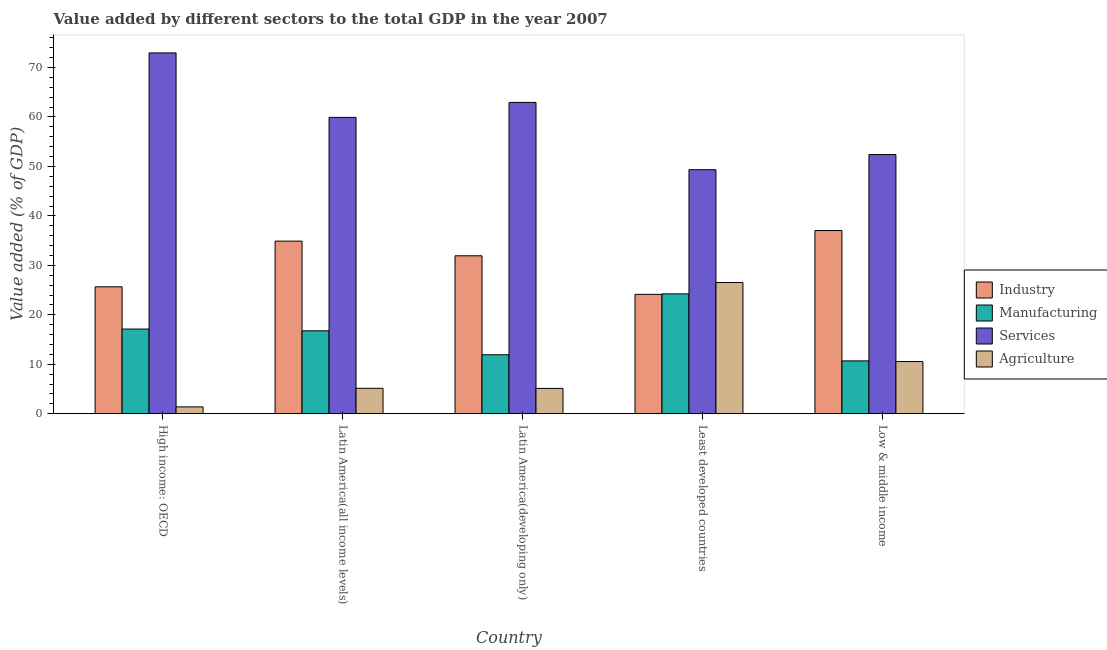How many different coloured bars are there?
Offer a terse response. 4. How many groups of bars are there?
Offer a very short reply. 5. Are the number of bars per tick equal to the number of legend labels?
Your answer should be very brief. Yes. Are the number of bars on each tick of the X-axis equal?
Offer a terse response. Yes. What is the value added by manufacturing sector in Low & middle income?
Offer a terse response. 10.68. Across all countries, what is the maximum value added by manufacturing sector?
Give a very brief answer. 24.24. Across all countries, what is the minimum value added by manufacturing sector?
Give a very brief answer. 10.68. In which country was the value added by industrial sector maximum?
Offer a terse response. Low & middle income. In which country was the value added by industrial sector minimum?
Provide a succinct answer. Least developed countries. What is the total value added by industrial sector in the graph?
Your answer should be compact. 153.68. What is the difference between the value added by services sector in Latin America(all income levels) and that in Latin America(developing only)?
Provide a succinct answer. -3.03. What is the difference between the value added by industrial sector in High income: OECD and the value added by services sector in Least developed countries?
Make the answer very short. -23.68. What is the average value added by manufacturing sector per country?
Your answer should be compact. 16.15. What is the difference between the value added by agricultural sector and value added by services sector in Latin America(all income levels)?
Make the answer very short. -54.77. In how many countries, is the value added by industrial sector greater than 38 %?
Offer a very short reply. 0. What is the ratio of the value added by manufacturing sector in High income: OECD to that in Least developed countries?
Keep it short and to the point. 0.71. Is the difference between the value added by manufacturing sector in High income: OECD and Latin America(developing only) greater than the difference between the value added by agricultural sector in High income: OECD and Latin America(developing only)?
Your response must be concise. Yes. What is the difference between the highest and the second highest value added by agricultural sector?
Offer a terse response. 15.98. What is the difference between the highest and the lowest value added by services sector?
Make the answer very short. 23.61. In how many countries, is the value added by services sector greater than the average value added by services sector taken over all countries?
Provide a short and direct response. 3. Is it the case that in every country, the sum of the value added by industrial sector and value added by manufacturing sector is greater than the sum of value added by agricultural sector and value added by services sector?
Your answer should be very brief. Yes. What does the 3rd bar from the left in High income: OECD represents?
Offer a terse response. Services. What does the 2nd bar from the right in Latin America(all income levels) represents?
Ensure brevity in your answer.  Services. Is it the case that in every country, the sum of the value added by industrial sector and value added by manufacturing sector is greater than the value added by services sector?
Ensure brevity in your answer.  No. How many bars are there?
Make the answer very short. 20. How many countries are there in the graph?
Give a very brief answer. 5. What is the difference between two consecutive major ticks on the Y-axis?
Your response must be concise. 10. Are the values on the major ticks of Y-axis written in scientific E-notation?
Make the answer very short. No. Where does the legend appear in the graph?
Make the answer very short. Center right. How many legend labels are there?
Your answer should be very brief. 4. What is the title of the graph?
Make the answer very short. Value added by different sectors to the total GDP in the year 2007. What is the label or title of the X-axis?
Offer a terse response. Country. What is the label or title of the Y-axis?
Provide a succinct answer. Value added (% of GDP). What is the Value added (% of GDP) of Industry in High income: OECD?
Make the answer very short. 25.67. What is the Value added (% of GDP) in Manufacturing in High income: OECD?
Ensure brevity in your answer.  17.12. What is the Value added (% of GDP) in Services in High income: OECD?
Offer a very short reply. 72.95. What is the Value added (% of GDP) in Agriculture in High income: OECD?
Offer a very short reply. 1.38. What is the Value added (% of GDP) of Industry in Latin America(all income levels)?
Offer a terse response. 34.9. What is the Value added (% of GDP) in Manufacturing in Latin America(all income levels)?
Your answer should be very brief. 16.76. What is the Value added (% of GDP) in Services in Latin America(all income levels)?
Provide a succinct answer. 59.92. What is the Value added (% of GDP) of Agriculture in Latin America(all income levels)?
Provide a short and direct response. 5.14. What is the Value added (% of GDP) in Industry in Latin America(developing only)?
Offer a very short reply. 31.93. What is the Value added (% of GDP) of Manufacturing in Latin America(developing only)?
Provide a short and direct response. 11.92. What is the Value added (% of GDP) of Services in Latin America(developing only)?
Offer a terse response. 62.94. What is the Value added (% of GDP) in Agriculture in Latin America(developing only)?
Your answer should be compact. 5.12. What is the Value added (% of GDP) in Industry in Least developed countries?
Provide a short and direct response. 24.14. What is the Value added (% of GDP) of Manufacturing in Least developed countries?
Give a very brief answer. 24.24. What is the Value added (% of GDP) in Services in Least developed countries?
Offer a very short reply. 49.34. What is the Value added (% of GDP) in Agriculture in Least developed countries?
Your response must be concise. 26.53. What is the Value added (% of GDP) of Industry in Low & middle income?
Offer a very short reply. 37.04. What is the Value added (% of GDP) in Manufacturing in Low & middle income?
Make the answer very short. 10.68. What is the Value added (% of GDP) of Services in Low & middle income?
Your answer should be very brief. 52.41. What is the Value added (% of GDP) in Agriculture in Low & middle income?
Give a very brief answer. 10.55. Across all countries, what is the maximum Value added (% of GDP) of Industry?
Ensure brevity in your answer.  37.04. Across all countries, what is the maximum Value added (% of GDP) in Manufacturing?
Your response must be concise. 24.24. Across all countries, what is the maximum Value added (% of GDP) of Services?
Give a very brief answer. 72.95. Across all countries, what is the maximum Value added (% of GDP) in Agriculture?
Offer a very short reply. 26.53. Across all countries, what is the minimum Value added (% of GDP) of Industry?
Provide a succinct answer. 24.14. Across all countries, what is the minimum Value added (% of GDP) of Manufacturing?
Provide a short and direct response. 10.68. Across all countries, what is the minimum Value added (% of GDP) of Services?
Provide a short and direct response. 49.34. Across all countries, what is the minimum Value added (% of GDP) of Agriculture?
Provide a succinct answer. 1.38. What is the total Value added (% of GDP) of Industry in the graph?
Give a very brief answer. 153.68. What is the total Value added (% of GDP) of Manufacturing in the graph?
Your answer should be compact. 80.73. What is the total Value added (% of GDP) of Services in the graph?
Your response must be concise. 297.56. What is the total Value added (% of GDP) in Agriculture in the graph?
Offer a terse response. 48.74. What is the difference between the Value added (% of GDP) in Industry in High income: OECD and that in Latin America(all income levels)?
Keep it short and to the point. -9.24. What is the difference between the Value added (% of GDP) of Manufacturing in High income: OECD and that in Latin America(all income levels)?
Make the answer very short. 0.36. What is the difference between the Value added (% of GDP) of Services in High income: OECD and that in Latin America(all income levels)?
Provide a succinct answer. 13.03. What is the difference between the Value added (% of GDP) in Agriculture in High income: OECD and that in Latin America(all income levels)?
Keep it short and to the point. -3.76. What is the difference between the Value added (% of GDP) of Industry in High income: OECD and that in Latin America(developing only)?
Ensure brevity in your answer.  -6.27. What is the difference between the Value added (% of GDP) of Manufacturing in High income: OECD and that in Latin America(developing only)?
Your answer should be very brief. 5.2. What is the difference between the Value added (% of GDP) in Services in High income: OECD and that in Latin America(developing only)?
Your answer should be compact. 10.01. What is the difference between the Value added (% of GDP) of Agriculture in High income: OECD and that in Latin America(developing only)?
Your response must be concise. -3.74. What is the difference between the Value added (% of GDP) of Industry in High income: OECD and that in Least developed countries?
Make the answer very short. 1.53. What is the difference between the Value added (% of GDP) in Manufacturing in High income: OECD and that in Least developed countries?
Provide a short and direct response. -7.12. What is the difference between the Value added (% of GDP) in Services in High income: OECD and that in Least developed countries?
Offer a terse response. 23.61. What is the difference between the Value added (% of GDP) in Agriculture in High income: OECD and that in Least developed countries?
Ensure brevity in your answer.  -25.15. What is the difference between the Value added (% of GDP) in Industry in High income: OECD and that in Low & middle income?
Offer a terse response. -11.37. What is the difference between the Value added (% of GDP) in Manufacturing in High income: OECD and that in Low & middle income?
Your response must be concise. 6.44. What is the difference between the Value added (% of GDP) of Services in High income: OECD and that in Low & middle income?
Your answer should be compact. 20.55. What is the difference between the Value added (% of GDP) in Agriculture in High income: OECD and that in Low & middle income?
Your response must be concise. -9.17. What is the difference between the Value added (% of GDP) of Industry in Latin America(all income levels) and that in Latin America(developing only)?
Offer a very short reply. 2.97. What is the difference between the Value added (% of GDP) of Manufacturing in Latin America(all income levels) and that in Latin America(developing only)?
Make the answer very short. 4.84. What is the difference between the Value added (% of GDP) of Services in Latin America(all income levels) and that in Latin America(developing only)?
Provide a short and direct response. -3.03. What is the difference between the Value added (% of GDP) of Agriculture in Latin America(all income levels) and that in Latin America(developing only)?
Give a very brief answer. 0.02. What is the difference between the Value added (% of GDP) of Industry in Latin America(all income levels) and that in Least developed countries?
Your answer should be compact. 10.77. What is the difference between the Value added (% of GDP) of Manufacturing in Latin America(all income levels) and that in Least developed countries?
Make the answer very short. -7.48. What is the difference between the Value added (% of GDP) in Services in Latin America(all income levels) and that in Least developed countries?
Make the answer very short. 10.58. What is the difference between the Value added (% of GDP) of Agriculture in Latin America(all income levels) and that in Least developed countries?
Provide a short and direct response. -21.39. What is the difference between the Value added (% of GDP) in Industry in Latin America(all income levels) and that in Low & middle income?
Provide a short and direct response. -2.14. What is the difference between the Value added (% of GDP) in Manufacturing in Latin America(all income levels) and that in Low & middle income?
Give a very brief answer. 6.08. What is the difference between the Value added (% of GDP) of Services in Latin America(all income levels) and that in Low & middle income?
Provide a succinct answer. 7.51. What is the difference between the Value added (% of GDP) in Agriculture in Latin America(all income levels) and that in Low & middle income?
Offer a very short reply. -5.41. What is the difference between the Value added (% of GDP) of Industry in Latin America(developing only) and that in Least developed countries?
Keep it short and to the point. 7.8. What is the difference between the Value added (% of GDP) of Manufacturing in Latin America(developing only) and that in Least developed countries?
Your answer should be very brief. -12.32. What is the difference between the Value added (% of GDP) of Services in Latin America(developing only) and that in Least developed countries?
Offer a terse response. 13.6. What is the difference between the Value added (% of GDP) of Agriculture in Latin America(developing only) and that in Least developed countries?
Provide a succinct answer. -21.41. What is the difference between the Value added (% of GDP) in Industry in Latin America(developing only) and that in Low & middle income?
Give a very brief answer. -5.11. What is the difference between the Value added (% of GDP) of Manufacturing in Latin America(developing only) and that in Low & middle income?
Your response must be concise. 1.24. What is the difference between the Value added (% of GDP) in Services in Latin America(developing only) and that in Low & middle income?
Offer a very short reply. 10.54. What is the difference between the Value added (% of GDP) in Agriculture in Latin America(developing only) and that in Low & middle income?
Ensure brevity in your answer.  -5.43. What is the difference between the Value added (% of GDP) of Industry in Least developed countries and that in Low & middle income?
Provide a succinct answer. -12.9. What is the difference between the Value added (% of GDP) of Manufacturing in Least developed countries and that in Low & middle income?
Your answer should be compact. 13.56. What is the difference between the Value added (% of GDP) of Services in Least developed countries and that in Low & middle income?
Your answer should be very brief. -3.06. What is the difference between the Value added (% of GDP) of Agriculture in Least developed countries and that in Low & middle income?
Make the answer very short. 15.98. What is the difference between the Value added (% of GDP) of Industry in High income: OECD and the Value added (% of GDP) of Manufacturing in Latin America(all income levels)?
Keep it short and to the point. 8.9. What is the difference between the Value added (% of GDP) of Industry in High income: OECD and the Value added (% of GDP) of Services in Latin America(all income levels)?
Keep it short and to the point. -34.25. What is the difference between the Value added (% of GDP) in Industry in High income: OECD and the Value added (% of GDP) in Agriculture in Latin America(all income levels)?
Give a very brief answer. 20.52. What is the difference between the Value added (% of GDP) of Manufacturing in High income: OECD and the Value added (% of GDP) of Services in Latin America(all income levels)?
Your answer should be very brief. -42.8. What is the difference between the Value added (% of GDP) in Manufacturing in High income: OECD and the Value added (% of GDP) in Agriculture in Latin America(all income levels)?
Give a very brief answer. 11.98. What is the difference between the Value added (% of GDP) of Services in High income: OECD and the Value added (% of GDP) of Agriculture in Latin America(all income levels)?
Ensure brevity in your answer.  67.81. What is the difference between the Value added (% of GDP) in Industry in High income: OECD and the Value added (% of GDP) in Manufacturing in Latin America(developing only)?
Your answer should be compact. 13.74. What is the difference between the Value added (% of GDP) in Industry in High income: OECD and the Value added (% of GDP) in Services in Latin America(developing only)?
Make the answer very short. -37.28. What is the difference between the Value added (% of GDP) of Industry in High income: OECD and the Value added (% of GDP) of Agriculture in Latin America(developing only)?
Ensure brevity in your answer.  20.54. What is the difference between the Value added (% of GDP) of Manufacturing in High income: OECD and the Value added (% of GDP) of Services in Latin America(developing only)?
Offer a very short reply. -45.82. What is the difference between the Value added (% of GDP) of Manufacturing in High income: OECD and the Value added (% of GDP) of Agriculture in Latin America(developing only)?
Keep it short and to the point. 12. What is the difference between the Value added (% of GDP) of Services in High income: OECD and the Value added (% of GDP) of Agriculture in Latin America(developing only)?
Your response must be concise. 67.83. What is the difference between the Value added (% of GDP) in Industry in High income: OECD and the Value added (% of GDP) in Manufacturing in Least developed countries?
Make the answer very short. 1.43. What is the difference between the Value added (% of GDP) in Industry in High income: OECD and the Value added (% of GDP) in Services in Least developed countries?
Ensure brevity in your answer.  -23.68. What is the difference between the Value added (% of GDP) of Industry in High income: OECD and the Value added (% of GDP) of Agriculture in Least developed countries?
Keep it short and to the point. -0.87. What is the difference between the Value added (% of GDP) in Manufacturing in High income: OECD and the Value added (% of GDP) in Services in Least developed countries?
Keep it short and to the point. -32.22. What is the difference between the Value added (% of GDP) of Manufacturing in High income: OECD and the Value added (% of GDP) of Agriculture in Least developed countries?
Your answer should be very brief. -9.41. What is the difference between the Value added (% of GDP) in Services in High income: OECD and the Value added (% of GDP) in Agriculture in Least developed countries?
Provide a short and direct response. 46.42. What is the difference between the Value added (% of GDP) of Industry in High income: OECD and the Value added (% of GDP) of Manufacturing in Low & middle income?
Provide a succinct answer. 14.98. What is the difference between the Value added (% of GDP) of Industry in High income: OECD and the Value added (% of GDP) of Services in Low & middle income?
Ensure brevity in your answer.  -26.74. What is the difference between the Value added (% of GDP) in Industry in High income: OECD and the Value added (% of GDP) in Agriculture in Low & middle income?
Keep it short and to the point. 15.11. What is the difference between the Value added (% of GDP) of Manufacturing in High income: OECD and the Value added (% of GDP) of Services in Low & middle income?
Offer a very short reply. -35.28. What is the difference between the Value added (% of GDP) of Manufacturing in High income: OECD and the Value added (% of GDP) of Agriculture in Low & middle income?
Your response must be concise. 6.57. What is the difference between the Value added (% of GDP) of Services in High income: OECD and the Value added (% of GDP) of Agriculture in Low & middle income?
Offer a terse response. 62.4. What is the difference between the Value added (% of GDP) of Industry in Latin America(all income levels) and the Value added (% of GDP) of Manufacturing in Latin America(developing only)?
Keep it short and to the point. 22.98. What is the difference between the Value added (% of GDP) in Industry in Latin America(all income levels) and the Value added (% of GDP) in Services in Latin America(developing only)?
Ensure brevity in your answer.  -28.04. What is the difference between the Value added (% of GDP) of Industry in Latin America(all income levels) and the Value added (% of GDP) of Agriculture in Latin America(developing only)?
Give a very brief answer. 29.78. What is the difference between the Value added (% of GDP) in Manufacturing in Latin America(all income levels) and the Value added (% of GDP) in Services in Latin America(developing only)?
Offer a very short reply. -46.18. What is the difference between the Value added (% of GDP) of Manufacturing in Latin America(all income levels) and the Value added (% of GDP) of Agriculture in Latin America(developing only)?
Keep it short and to the point. 11.64. What is the difference between the Value added (% of GDP) of Services in Latin America(all income levels) and the Value added (% of GDP) of Agriculture in Latin America(developing only)?
Give a very brief answer. 54.79. What is the difference between the Value added (% of GDP) of Industry in Latin America(all income levels) and the Value added (% of GDP) of Manufacturing in Least developed countries?
Give a very brief answer. 10.66. What is the difference between the Value added (% of GDP) of Industry in Latin America(all income levels) and the Value added (% of GDP) of Services in Least developed countries?
Provide a succinct answer. -14.44. What is the difference between the Value added (% of GDP) in Industry in Latin America(all income levels) and the Value added (% of GDP) in Agriculture in Least developed countries?
Ensure brevity in your answer.  8.37. What is the difference between the Value added (% of GDP) of Manufacturing in Latin America(all income levels) and the Value added (% of GDP) of Services in Least developed countries?
Make the answer very short. -32.58. What is the difference between the Value added (% of GDP) in Manufacturing in Latin America(all income levels) and the Value added (% of GDP) in Agriculture in Least developed countries?
Ensure brevity in your answer.  -9.77. What is the difference between the Value added (% of GDP) of Services in Latin America(all income levels) and the Value added (% of GDP) of Agriculture in Least developed countries?
Offer a very short reply. 33.38. What is the difference between the Value added (% of GDP) in Industry in Latin America(all income levels) and the Value added (% of GDP) in Manufacturing in Low & middle income?
Keep it short and to the point. 24.22. What is the difference between the Value added (% of GDP) in Industry in Latin America(all income levels) and the Value added (% of GDP) in Services in Low & middle income?
Offer a very short reply. -17.5. What is the difference between the Value added (% of GDP) in Industry in Latin America(all income levels) and the Value added (% of GDP) in Agriculture in Low & middle income?
Offer a terse response. 24.35. What is the difference between the Value added (% of GDP) in Manufacturing in Latin America(all income levels) and the Value added (% of GDP) in Services in Low & middle income?
Offer a very short reply. -35.64. What is the difference between the Value added (% of GDP) in Manufacturing in Latin America(all income levels) and the Value added (% of GDP) in Agriculture in Low & middle income?
Your response must be concise. 6.21. What is the difference between the Value added (% of GDP) in Services in Latin America(all income levels) and the Value added (% of GDP) in Agriculture in Low & middle income?
Make the answer very short. 49.36. What is the difference between the Value added (% of GDP) of Industry in Latin America(developing only) and the Value added (% of GDP) of Manufacturing in Least developed countries?
Your answer should be compact. 7.69. What is the difference between the Value added (% of GDP) of Industry in Latin America(developing only) and the Value added (% of GDP) of Services in Least developed countries?
Make the answer very short. -17.41. What is the difference between the Value added (% of GDP) of Industry in Latin America(developing only) and the Value added (% of GDP) of Agriculture in Least developed countries?
Offer a very short reply. 5.4. What is the difference between the Value added (% of GDP) in Manufacturing in Latin America(developing only) and the Value added (% of GDP) in Services in Least developed countries?
Your response must be concise. -37.42. What is the difference between the Value added (% of GDP) in Manufacturing in Latin America(developing only) and the Value added (% of GDP) in Agriculture in Least developed countries?
Ensure brevity in your answer.  -14.61. What is the difference between the Value added (% of GDP) in Services in Latin America(developing only) and the Value added (% of GDP) in Agriculture in Least developed countries?
Provide a succinct answer. 36.41. What is the difference between the Value added (% of GDP) in Industry in Latin America(developing only) and the Value added (% of GDP) in Manufacturing in Low & middle income?
Make the answer very short. 21.25. What is the difference between the Value added (% of GDP) in Industry in Latin America(developing only) and the Value added (% of GDP) in Services in Low & middle income?
Your answer should be compact. -20.47. What is the difference between the Value added (% of GDP) of Industry in Latin America(developing only) and the Value added (% of GDP) of Agriculture in Low & middle income?
Ensure brevity in your answer.  21.38. What is the difference between the Value added (% of GDP) of Manufacturing in Latin America(developing only) and the Value added (% of GDP) of Services in Low & middle income?
Ensure brevity in your answer.  -40.48. What is the difference between the Value added (% of GDP) in Manufacturing in Latin America(developing only) and the Value added (% of GDP) in Agriculture in Low & middle income?
Your answer should be very brief. 1.37. What is the difference between the Value added (% of GDP) in Services in Latin America(developing only) and the Value added (% of GDP) in Agriculture in Low & middle income?
Give a very brief answer. 52.39. What is the difference between the Value added (% of GDP) of Industry in Least developed countries and the Value added (% of GDP) of Manufacturing in Low & middle income?
Offer a terse response. 13.45. What is the difference between the Value added (% of GDP) of Industry in Least developed countries and the Value added (% of GDP) of Services in Low & middle income?
Provide a succinct answer. -28.27. What is the difference between the Value added (% of GDP) in Industry in Least developed countries and the Value added (% of GDP) in Agriculture in Low & middle income?
Ensure brevity in your answer.  13.58. What is the difference between the Value added (% of GDP) in Manufacturing in Least developed countries and the Value added (% of GDP) in Services in Low & middle income?
Your answer should be very brief. -28.17. What is the difference between the Value added (% of GDP) in Manufacturing in Least developed countries and the Value added (% of GDP) in Agriculture in Low & middle income?
Keep it short and to the point. 13.69. What is the difference between the Value added (% of GDP) in Services in Least developed countries and the Value added (% of GDP) in Agriculture in Low & middle income?
Give a very brief answer. 38.79. What is the average Value added (% of GDP) in Industry per country?
Your answer should be very brief. 30.74. What is the average Value added (% of GDP) of Manufacturing per country?
Your response must be concise. 16.15. What is the average Value added (% of GDP) in Services per country?
Give a very brief answer. 59.51. What is the average Value added (% of GDP) in Agriculture per country?
Your answer should be compact. 9.75. What is the difference between the Value added (% of GDP) in Industry and Value added (% of GDP) in Manufacturing in High income: OECD?
Give a very brief answer. 8.54. What is the difference between the Value added (% of GDP) in Industry and Value added (% of GDP) in Services in High income: OECD?
Give a very brief answer. -47.29. What is the difference between the Value added (% of GDP) in Industry and Value added (% of GDP) in Agriculture in High income: OECD?
Give a very brief answer. 24.28. What is the difference between the Value added (% of GDP) of Manufacturing and Value added (% of GDP) of Services in High income: OECD?
Keep it short and to the point. -55.83. What is the difference between the Value added (% of GDP) in Manufacturing and Value added (% of GDP) in Agriculture in High income: OECD?
Give a very brief answer. 15.74. What is the difference between the Value added (% of GDP) in Services and Value added (% of GDP) in Agriculture in High income: OECD?
Give a very brief answer. 71.57. What is the difference between the Value added (% of GDP) of Industry and Value added (% of GDP) of Manufacturing in Latin America(all income levels)?
Make the answer very short. 18.14. What is the difference between the Value added (% of GDP) of Industry and Value added (% of GDP) of Services in Latin America(all income levels)?
Provide a succinct answer. -25.01. What is the difference between the Value added (% of GDP) of Industry and Value added (% of GDP) of Agriculture in Latin America(all income levels)?
Provide a short and direct response. 29.76. What is the difference between the Value added (% of GDP) of Manufacturing and Value added (% of GDP) of Services in Latin America(all income levels)?
Give a very brief answer. -43.15. What is the difference between the Value added (% of GDP) of Manufacturing and Value added (% of GDP) of Agriculture in Latin America(all income levels)?
Offer a terse response. 11.62. What is the difference between the Value added (% of GDP) of Services and Value added (% of GDP) of Agriculture in Latin America(all income levels)?
Provide a succinct answer. 54.77. What is the difference between the Value added (% of GDP) of Industry and Value added (% of GDP) of Manufacturing in Latin America(developing only)?
Provide a short and direct response. 20.01. What is the difference between the Value added (% of GDP) of Industry and Value added (% of GDP) of Services in Latin America(developing only)?
Your answer should be compact. -31.01. What is the difference between the Value added (% of GDP) of Industry and Value added (% of GDP) of Agriculture in Latin America(developing only)?
Your response must be concise. 26.81. What is the difference between the Value added (% of GDP) of Manufacturing and Value added (% of GDP) of Services in Latin America(developing only)?
Offer a terse response. -51.02. What is the difference between the Value added (% of GDP) in Manufacturing and Value added (% of GDP) in Agriculture in Latin America(developing only)?
Provide a short and direct response. 6.8. What is the difference between the Value added (% of GDP) in Services and Value added (% of GDP) in Agriculture in Latin America(developing only)?
Make the answer very short. 57.82. What is the difference between the Value added (% of GDP) in Industry and Value added (% of GDP) in Manufacturing in Least developed countries?
Provide a short and direct response. -0.1. What is the difference between the Value added (% of GDP) of Industry and Value added (% of GDP) of Services in Least developed countries?
Offer a very short reply. -25.21. What is the difference between the Value added (% of GDP) of Industry and Value added (% of GDP) of Agriculture in Least developed countries?
Make the answer very short. -2.4. What is the difference between the Value added (% of GDP) in Manufacturing and Value added (% of GDP) in Services in Least developed countries?
Give a very brief answer. -25.1. What is the difference between the Value added (% of GDP) in Manufacturing and Value added (% of GDP) in Agriculture in Least developed countries?
Offer a terse response. -2.29. What is the difference between the Value added (% of GDP) in Services and Value added (% of GDP) in Agriculture in Least developed countries?
Offer a very short reply. 22.81. What is the difference between the Value added (% of GDP) of Industry and Value added (% of GDP) of Manufacturing in Low & middle income?
Ensure brevity in your answer.  26.36. What is the difference between the Value added (% of GDP) of Industry and Value added (% of GDP) of Services in Low & middle income?
Offer a very short reply. -15.37. What is the difference between the Value added (% of GDP) of Industry and Value added (% of GDP) of Agriculture in Low & middle income?
Offer a very short reply. 26.49. What is the difference between the Value added (% of GDP) in Manufacturing and Value added (% of GDP) in Services in Low & middle income?
Ensure brevity in your answer.  -41.72. What is the difference between the Value added (% of GDP) of Manufacturing and Value added (% of GDP) of Agriculture in Low & middle income?
Give a very brief answer. 0.13. What is the difference between the Value added (% of GDP) of Services and Value added (% of GDP) of Agriculture in Low & middle income?
Keep it short and to the point. 41.85. What is the ratio of the Value added (% of GDP) in Industry in High income: OECD to that in Latin America(all income levels)?
Offer a very short reply. 0.74. What is the ratio of the Value added (% of GDP) of Manufacturing in High income: OECD to that in Latin America(all income levels)?
Provide a succinct answer. 1.02. What is the ratio of the Value added (% of GDP) in Services in High income: OECD to that in Latin America(all income levels)?
Ensure brevity in your answer.  1.22. What is the ratio of the Value added (% of GDP) of Agriculture in High income: OECD to that in Latin America(all income levels)?
Provide a short and direct response. 0.27. What is the ratio of the Value added (% of GDP) in Industry in High income: OECD to that in Latin America(developing only)?
Provide a short and direct response. 0.8. What is the ratio of the Value added (% of GDP) of Manufacturing in High income: OECD to that in Latin America(developing only)?
Offer a very short reply. 1.44. What is the ratio of the Value added (% of GDP) in Services in High income: OECD to that in Latin America(developing only)?
Ensure brevity in your answer.  1.16. What is the ratio of the Value added (% of GDP) of Agriculture in High income: OECD to that in Latin America(developing only)?
Ensure brevity in your answer.  0.27. What is the ratio of the Value added (% of GDP) of Industry in High income: OECD to that in Least developed countries?
Give a very brief answer. 1.06. What is the ratio of the Value added (% of GDP) of Manufacturing in High income: OECD to that in Least developed countries?
Keep it short and to the point. 0.71. What is the ratio of the Value added (% of GDP) of Services in High income: OECD to that in Least developed countries?
Provide a short and direct response. 1.48. What is the ratio of the Value added (% of GDP) of Agriculture in High income: OECD to that in Least developed countries?
Make the answer very short. 0.05. What is the ratio of the Value added (% of GDP) in Industry in High income: OECD to that in Low & middle income?
Your answer should be very brief. 0.69. What is the ratio of the Value added (% of GDP) in Manufacturing in High income: OECD to that in Low & middle income?
Your response must be concise. 1.6. What is the ratio of the Value added (% of GDP) of Services in High income: OECD to that in Low & middle income?
Offer a very short reply. 1.39. What is the ratio of the Value added (% of GDP) in Agriculture in High income: OECD to that in Low & middle income?
Make the answer very short. 0.13. What is the ratio of the Value added (% of GDP) of Industry in Latin America(all income levels) to that in Latin America(developing only)?
Offer a very short reply. 1.09. What is the ratio of the Value added (% of GDP) of Manufacturing in Latin America(all income levels) to that in Latin America(developing only)?
Your answer should be very brief. 1.41. What is the ratio of the Value added (% of GDP) of Services in Latin America(all income levels) to that in Latin America(developing only)?
Your response must be concise. 0.95. What is the ratio of the Value added (% of GDP) of Agriculture in Latin America(all income levels) to that in Latin America(developing only)?
Your answer should be compact. 1. What is the ratio of the Value added (% of GDP) in Industry in Latin America(all income levels) to that in Least developed countries?
Your response must be concise. 1.45. What is the ratio of the Value added (% of GDP) of Manufacturing in Latin America(all income levels) to that in Least developed countries?
Your answer should be compact. 0.69. What is the ratio of the Value added (% of GDP) in Services in Latin America(all income levels) to that in Least developed countries?
Your response must be concise. 1.21. What is the ratio of the Value added (% of GDP) of Agriculture in Latin America(all income levels) to that in Least developed countries?
Ensure brevity in your answer.  0.19. What is the ratio of the Value added (% of GDP) in Industry in Latin America(all income levels) to that in Low & middle income?
Your answer should be compact. 0.94. What is the ratio of the Value added (% of GDP) in Manufacturing in Latin America(all income levels) to that in Low & middle income?
Offer a terse response. 1.57. What is the ratio of the Value added (% of GDP) in Services in Latin America(all income levels) to that in Low & middle income?
Your response must be concise. 1.14. What is the ratio of the Value added (% of GDP) of Agriculture in Latin America(all income levels) to that in Low & middle income?
Provide a succinct answer. 0.49. What is the ratio of the Value added (% of GDP) of Industry in Latin America(developing only) to that in Least developed countries?
Offer a very short reply. 1.32. What is the ratio of the Value added (% of GDP) in Manufacturing in Latin America(developing only) to that in Least developed countries?
Keep it short and to the point. 0.49. What is the ratio of the Value added (% of GDP) in Services in Latin America(developing only) to that in Least developed countries?
Your response must be concise. 1.28. What is the ratio of the Value added (% of GDP) in Agriculture in Latin America(developing only) to that in Least developed countries?
Make the answer very short. 0.19. What is the ratio of the Value added (% of GDP) in Industry in Latin America(developing only) to that in Low & middle income?
Keep it short and to the point. 0.86. What is the ratio of the Value added (% of GDP) in Manufacturing in Latin America(developing only) to that in Low & middle income?
Offer a terse response. 1.12. What is the ratio of the Value added (% of GDP) in Services in Latin America(developing only) to that in Low & middle income?
Offer a terse response. 1.2. What is the ratio of the Value added (% of GDP) in Agriculture in Latin America(developing only) to that in Low & middle income?
Give a very brief answer. 0.49. What is the ratio of the Value added (% of GDP) in Industry in Least developed countries to that in Low & middle income?
Your answer should be very brief. 0.65. What is the ratio of the Value added (% of GDP) in Manufacturing in Least developed countries to that in Low & middle income?
Offer a terse response. 2.27. What is the ratio of the Value added (% of GDP) of Services in Least developed countries to that in Low & middle income?
Your answer should be very brief. 0.94. What is the ratio of the Value added (% of GDP) of Agriculture in Least developed countries to that in Low & middle income?
Your response must be concise. 2.51. What is the difference between the highest and the second highest Value added (% of GDP) in Industry?
Offer a terse response. 2.14. What is the difference between the highest and the second highest Value added (% of GDP) of Manufacturing?
Your answer should be compact. 7.12. What is the difference between the highest and the second highest Value added (% of GDP) in Services?
Make the answer very short. 10.01. What is the difference between the highest and the second highest Value added (% of GDP) of Agriculture?
Ensure brevity in your answer.  15.98. What is the difference between the highest and the lowest Value added (% of GDP) of Industry?
Ensure brevity in your answer.  12.9. What is the difference between the highest and the lowest Value added (% of GDP) in Manufacturing?
Your response must be concise. 13.56. What is the difference between the highest and the lowest Value added (% of GDP) in Services?
Make the answer very short. 23.61. What is the difference between the highest and the lowest Value added (% of GDP) of Agriculture?
Give a very brief answer. 25.15. 